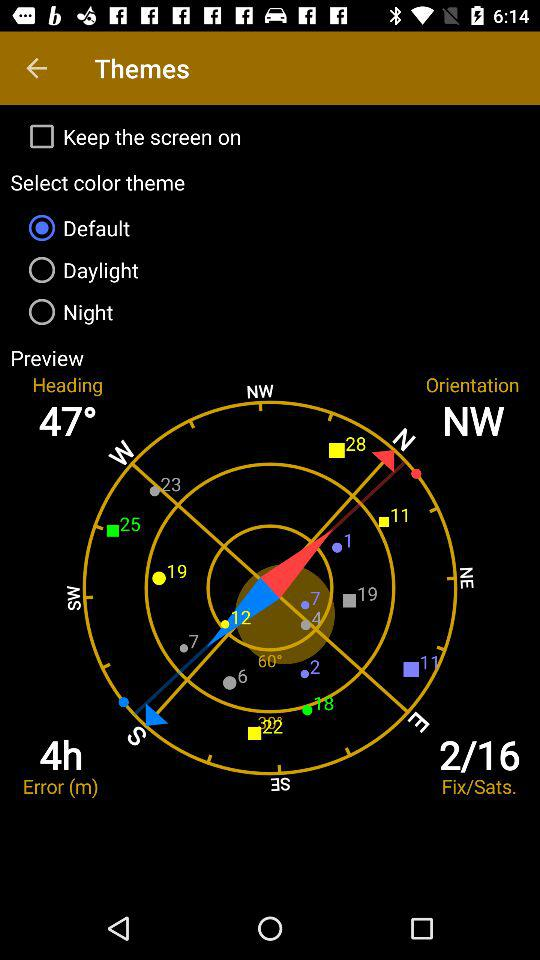How many error hours? There are four error hours. 